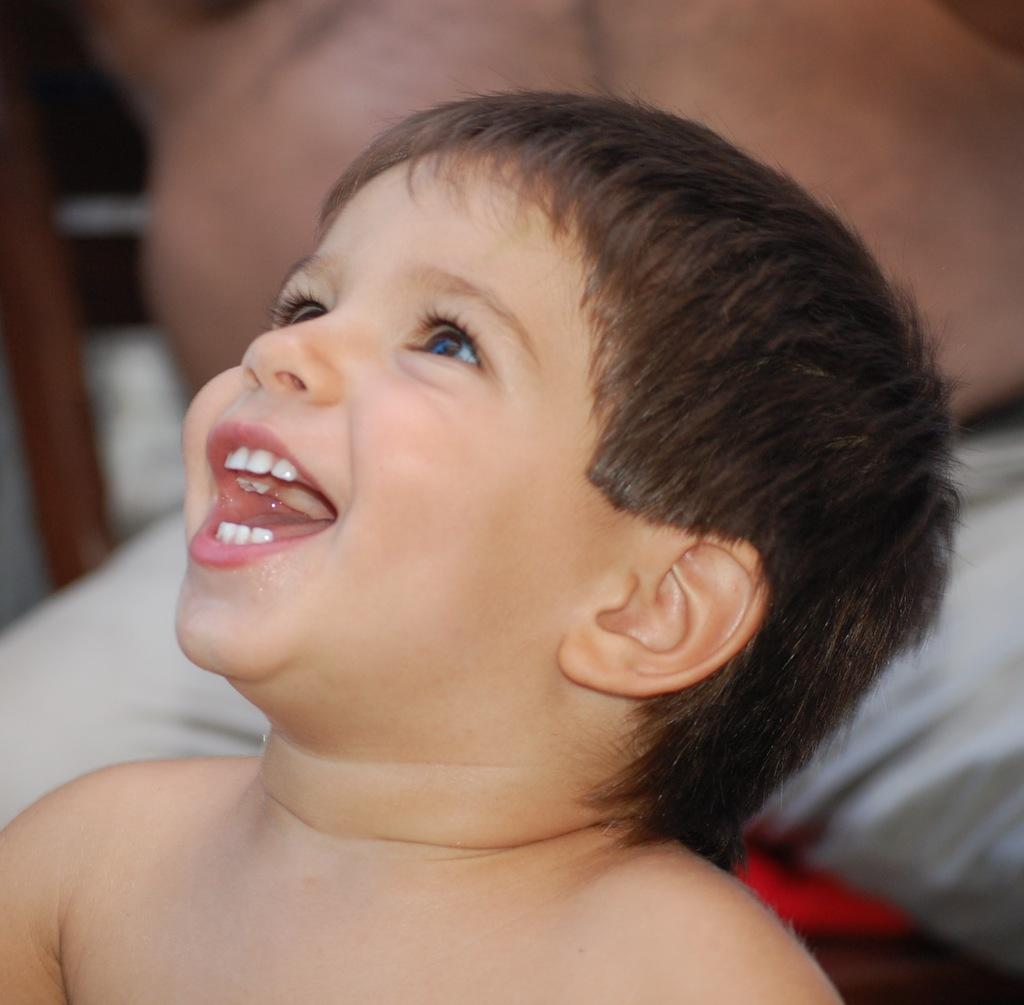Who is the main subject in the image? There is a boy in the image. What is the boy doing in the image? The boy is smiling in the image. Can you describe the background of the image? There is a person sitting on a chair in the background of the image. What type of seed is the baby holding in the image? There is no seed or baby present in the image. What part of the image is the baby located in? There is no baby present in the image. 